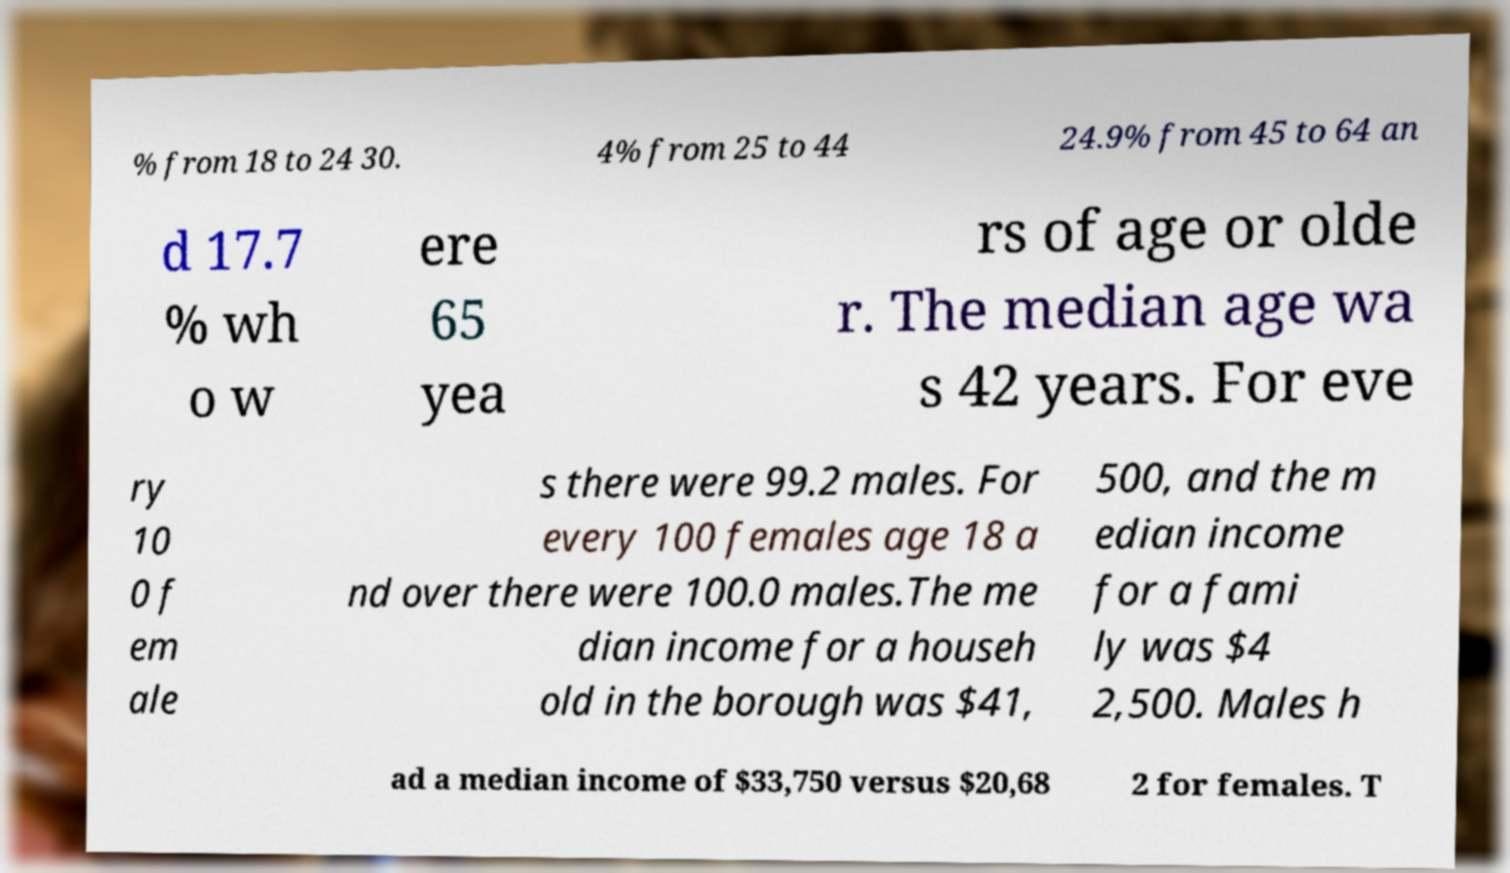Please identify and transcribe the text found in this image. % from 18 to 24 30. 4% from 25 to 44 24.9% from 45 to 64 an d 17.7 % wh o w ere 65 yea rs of age or olde r. The median age wa s 42 years. For eve ry 10 0 f em ale s there were 99.2 males. For every 100 females age 18 a nd over there were 100.0 males.The me dian income for a househ old in the borough was $41, 500, and the m edian income for a fami ly was $4 2,500. Males h ad a median income of $33,750 versus $20,68 2 for females. T 